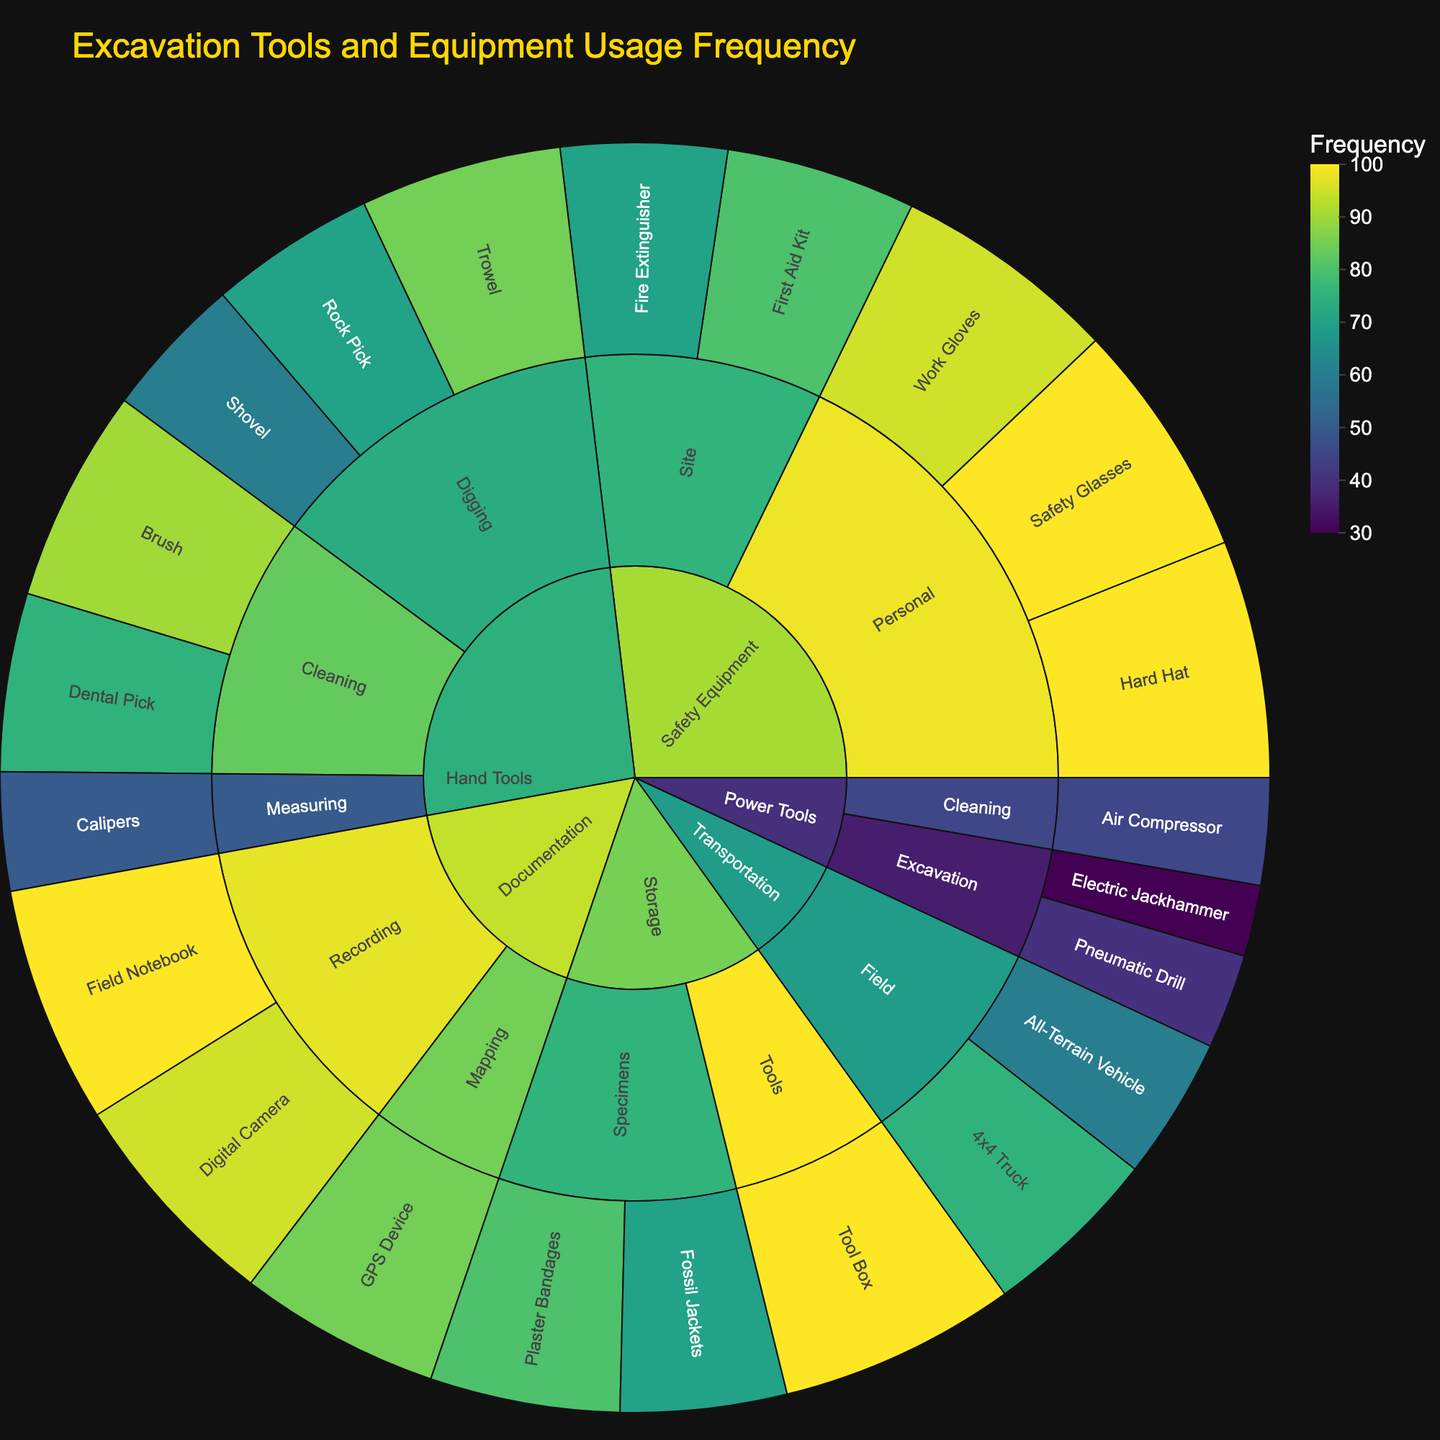What is the most frequently used piece of hand tool for cleaning? Identify the “Hand Tools” category, then the “Cleaning” subcategory, and then find the item with the highest frequency. The Brush has a frequency of 90.
Answer: Brush Which category contains the item with the highest usage frequency? Look for the item with the highest frequency across all categories. The “Safety Equipment” category contains the Hard Hat and Safety Glasses, both with a frequency of 100.
Answer: Safety Equipment What are the total frequencies of transportation tools? Sum the frequencies of items under “Transportation” (All-Terrain Vehicle and 4x4 Truck). 60 + 75 = 135.
Answer: 135 Is the frequency of using Trowel higher than Shovel? Compare the frequencies of Trowel (85) and Shovel (60).
Answer: Yes Which has a higher frequency: Digital Camera or Electric Jackhammer? Compare the frequency of Digital Camera (95) and Electric Jackhammer (30).
Answer: Digital Camera How does the frequency of using Work Gloves compare to using Air Compressor? Compare Work Gloves (95) with Air Compressor (45). Work Gloves have a higher frequency.
Answer: Work Gloves Total frequency of all “Storage” category items? Sum frequencies of items in Storage category (Tool Box, Plaster Bandages, Fossil Jackets). 100 + 80 + 70 = 250.
Answer: 250 What is the least frequently used Power Tool for excavation? Identify the “Power Tools” category, then the “Excavation” subcategory, and find the item with the lowest frequency, which is Electric Jackhammer (30).
Answer: Electric Jackhammer Which item under Safety Equipment is needed at the Site with the highest frequency? In the “Safety Equipment” category, under “Site” subcategory, First Aid Kit (80) has the highest frequency compared to Fire Extinguisher (70).
Answer: First Aid Kit What is the combined frequency of the most used items in each category? Add the highest frequency items in each category: Hard Hat (100) from Safety Equipment, Brush (90) from Hand Tools, Tool Box (100) from Storage, Field Notebook (100) from Documentation, All-Terrain Vehicle (75) from Transportation, and Pneumatic Drill (40) from Power Tools. 100 + 90 + 100 + 100 + 75 + 40 = 505
Answer: 505 